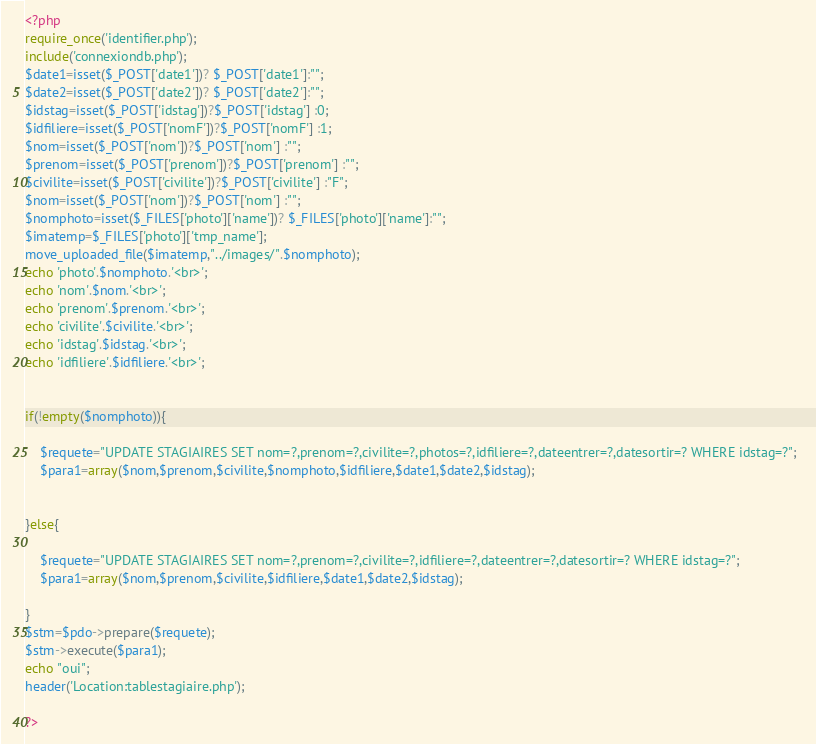Convert code to text. <code><loc_0><loc_0><loc_500><loc_500><_PHP_><?php
require_once('identifier.php');
include('connexiondb.php');
$date1=isset($_POST['date1'])? $_POST['date1']:"";
$date2=isset($_POST['date2'])? $_POST['date2']:"";
$idstag=isset($_POST['idstag'])?$_POST['idstag'] :0;
$idfiliere=isset($_POST['nomF'])?$_POST['nomF'] :1;
$nom=isset($_POST['nom'])?$_POST['nom'] :"";
$prenom=isset($_POST['prenom'])?$_POST['prenom'] :"";
$civilite=isset($_POST['civilite'])?$_POST['civilite'] :"F";
$nom=isset($_POST['nom'])?$_POST['nom'] :"";
$nomphoto=isset($_FILES['photo']['name'])? $_FILES['photo']['name']:"";
$imatemp=$_FILES['photo']['tmp_name'];
move_uploaded_file($imatemp,"../images/".$nomphoto);
echo 'photo'.$nomphoto.'<br>';
echo 'nom'.$nom.'<br>';
echo 'prenom'.$prenom.'<br>';
echo 'civilite'.$civilite.'<br>';
echo 'idstag'.$idstag.'<br>';
echo 'idfiliere'.$idfiliere.'<br>';


if(!empty($nomphoto)){
          
    $requete="UPDATE STAGIAIRES SET nom=?,prenom=?,civilite=?,photos=?,idfiliere=?,dateentrer=?,datesortir=? WHERE idstag=?";  
    $para1=array($nom,$prenom,$civilite,$nomphoto,$idfiliere,$date1,$date2,$idstag);
 
  
}else{

    $requete="UPDATE STAGIAIRES SET nom=?,prenom=?,civilite=?,idfiliere=?,dateentrer=?,datesortir=? WHERE idstag=?";  
    $para1=array($nom,$prenom,$civilite,$idfiliere,$date1,$date2,$idstag);

}
$stm=$pdo->prepare($requete);
$stm->execute($para1);
echo "oui";
header('Location:tablestagiaire.php');

?></code> 